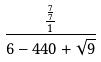Convert formula to latex. <formula><loc_0><loc_0><loc_500><loc_500>\frac { \frac { \frac { 7 } { 7 } } { 1 } } { 6 - 4 4 0 + \sqrt { 9 } }</formula> 